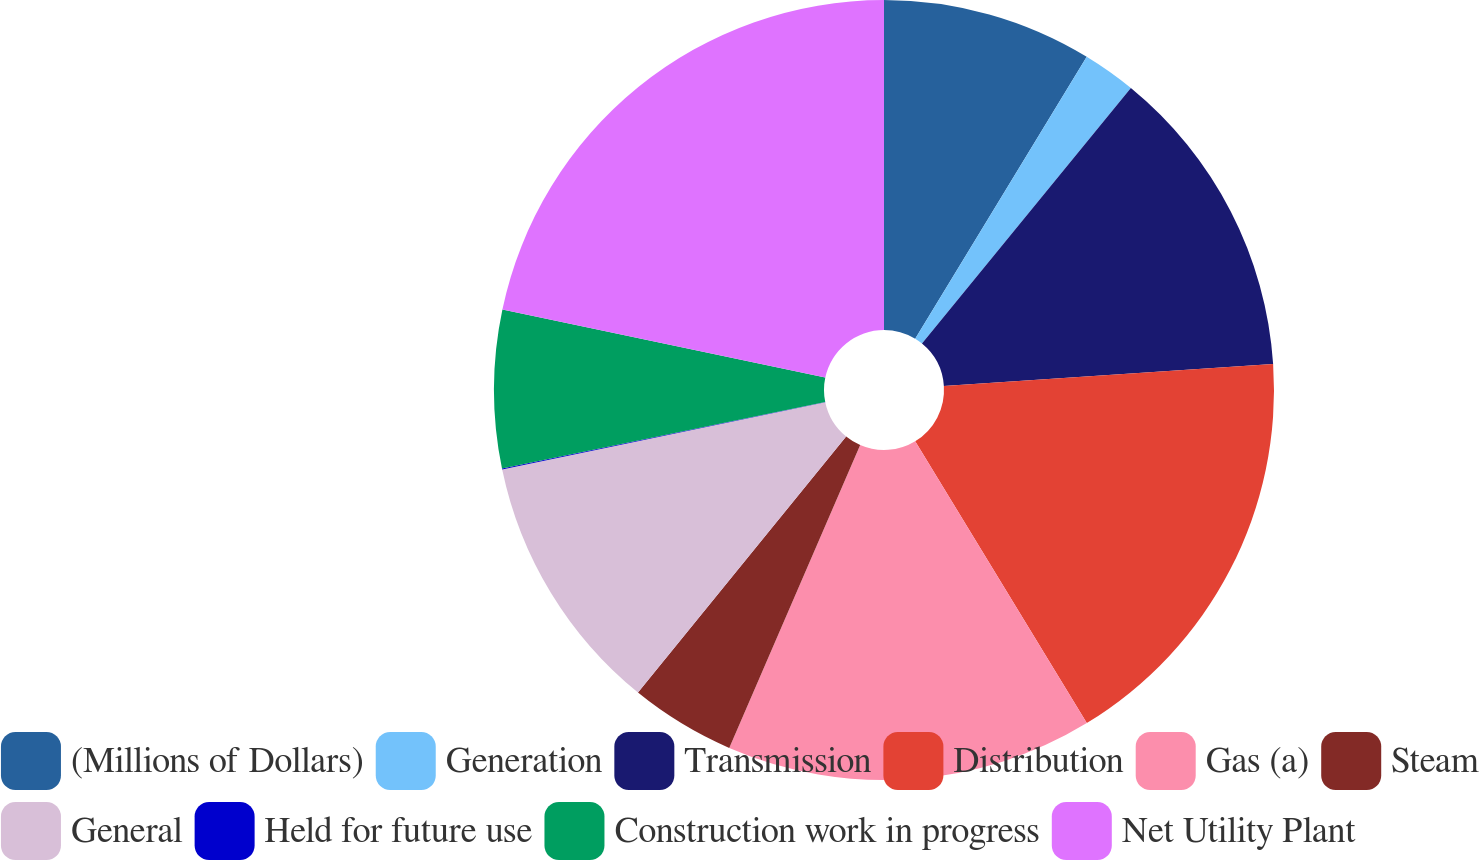Convert chart to OTSL. <chart><loc_0><loc_0><loc_500><loc_500><pie_chart><fcel>(Millions of Dollars)<fcel>Generation<fcel>Transmission<fcel>Distribution<fcel>Gas (a)<fcel>Steam<fcel>General<fcel>Held for future use<fcel>Construction work in progress<fcel>Net Utility Plant<nl><fcel>8.7%<fcel>2.21%<fcel>13.03%<fcel>17.36%<fcel>15.2%<fcel>4.37%<fcel>10.87%<fcel>0.04%<fcel>6.54%<fcel>21.69%<nl></chart> 